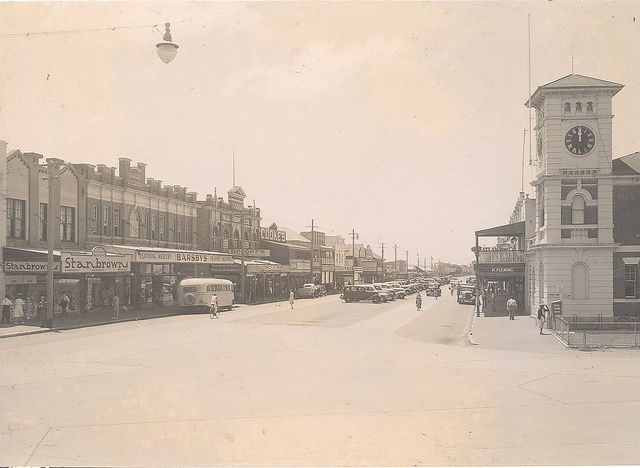Describe the objects in this image and their specific colors. I can see bus in white, darkgray, and gray tones, clock in white, gray, and darkgray tones, truck in white, gray, and darkgray tones, car in white, gray, and darkgray tones, and truck in white, gray, darkgray, and lightgray tones in this image. 